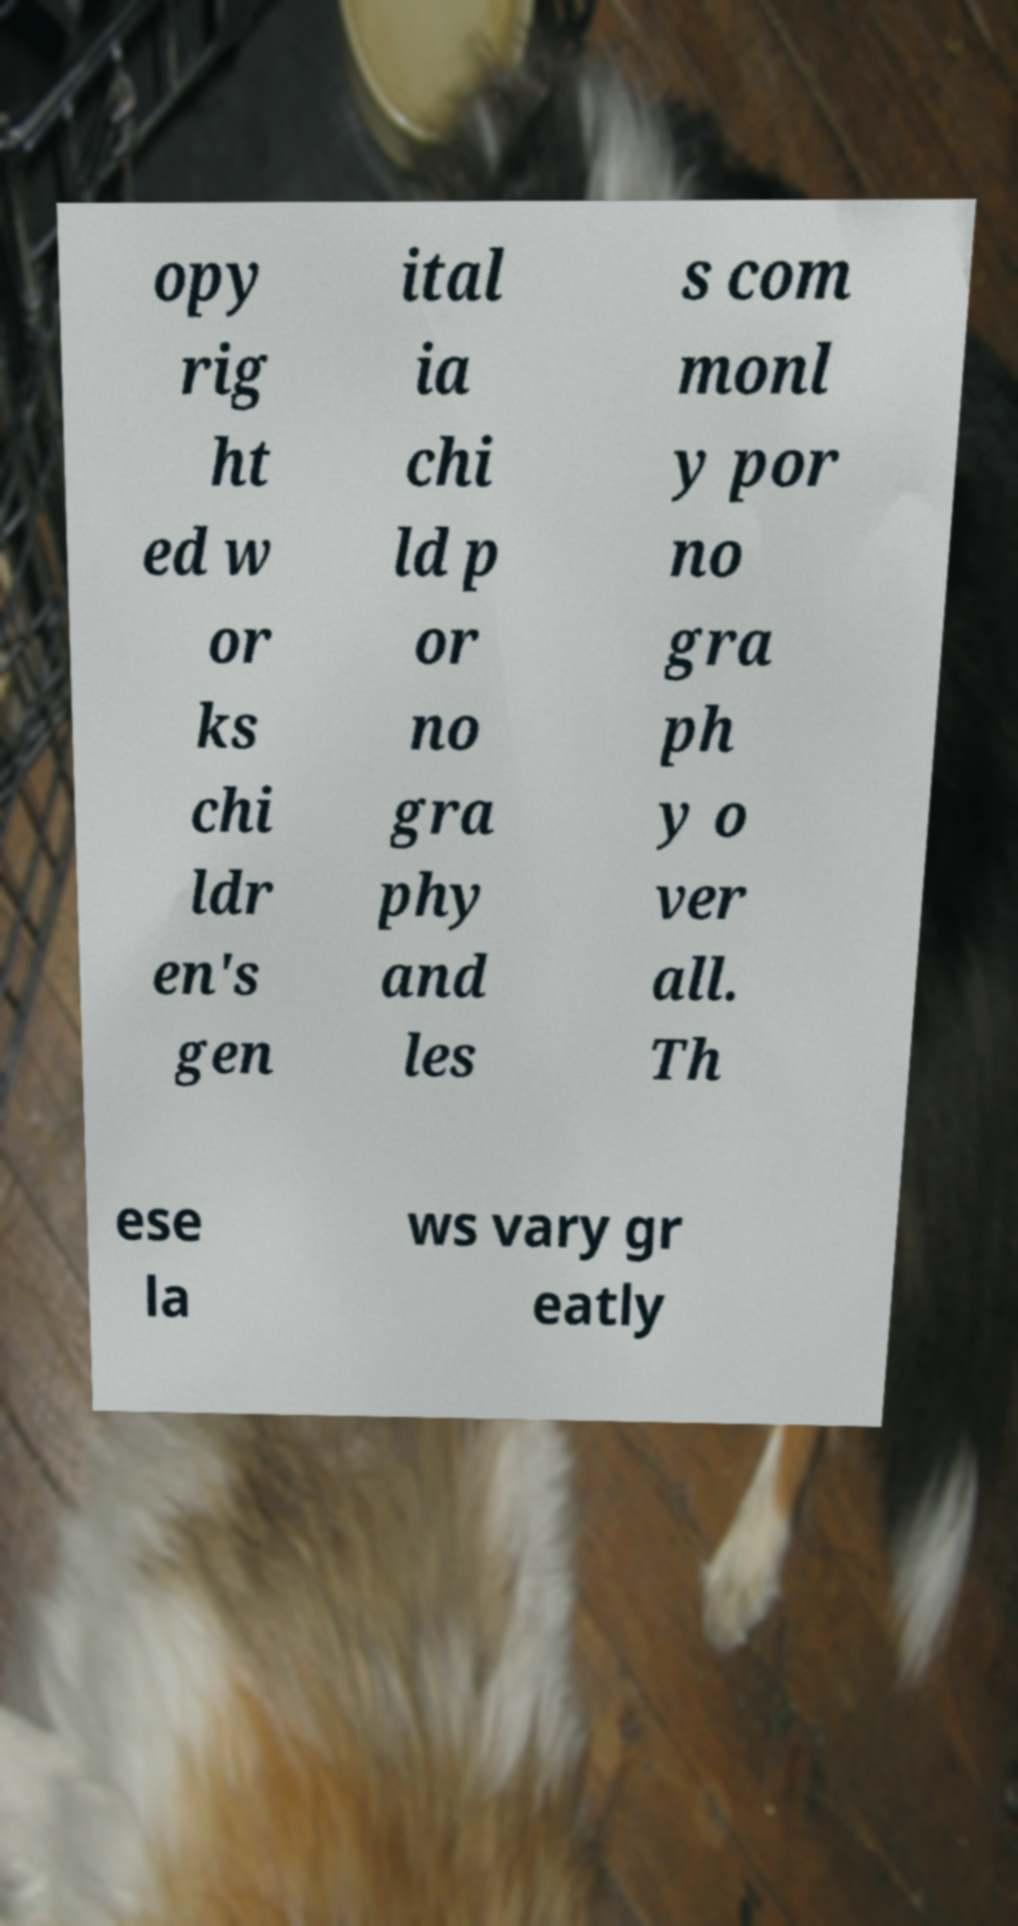Please identify and transcribe the text found in this image. opy rig ht ed w or ks chi ldr en's gen ital ia chi ld p or no gra phy and les s com monl y por no gra ph y o ver all. Th ese la ws vary gr eatly 